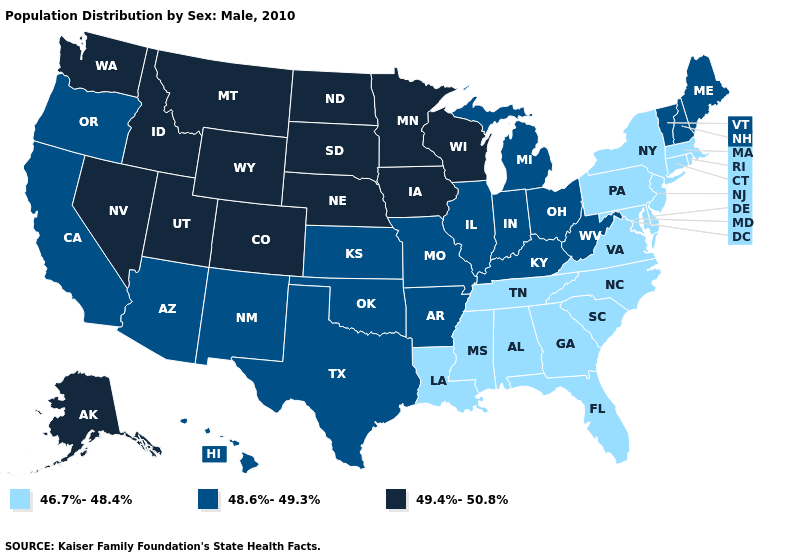Does Florida have the lowest value in the USA?
Write a very short answer. Yes. What is the value of Maine?
Write a very short answer. 48.6%-49.3%. Which states have the lowest value in the USA?
Concise answer only. Alabama, Connecticut, Delaware, Florida, Georgia, Louisiana, Maryland, Massachusetts, Mississippi, New Jersey, New York, North Carolina, Pennsylvania, Rhode Island, South Carolina, Tennessee, Virginia. Among the states that border New Hampshire , which have the lowest value?
Be succinct. Massachusetts. Name the states that have a value in the range 48.6%-49.3%?
Answer briefly. Arizona, Arkansas, California, Hawaii, Illinois, Indiana, Kansas, Kentucky, Maine, Michigan, Missouri, New Hampshire, New Mexico, Ohio, Oklahoma, Oregon, Texas, Vermont, West Virginia. How many symbols are there in the legend?
Be succinct. 3. Name the states that have a value in the range 46.7%-48.4%?
Be succinct. Alabama, Connecticut, Delaware, Florida, Georgia, Louisiana, Maryland, Massachusetts, Mississippi, New Jersey, New York, North Carolina, Pennsylvania, Rhode Island, South Carolina, Tennessee, Virginia. Is the legend a continuous bar?
Concise answer only. No. Name the states that have a value in the range 48.6%-49.3%?
Be succinct. Arizona, Arkansas, California, Hawaii, Illinois, Indiana, Kansas, Kentucky, Maine, Michigan, Missouri, New Hampshire, New Mexico, Ohio, Oklahoma, Oregon, Texas, Vermont, West Virginia. Among the states that border Nebraska , which have the highest value?
Short answer required. Colorado, Iowa, South Dakota, Wyoming. Name the states that have a value in the range 49.4%-50.8%?
Short answer required. Alaska, Colorado, Idaho, Iowa, Minnesota, Montana, Nebraska, Nevada, North Dakota, South Dakota, Utah, Washington, Wisconsin, Wyoming. How many symbols are there in the legend?
Write a very short answer. 3. Name the states that have a value in the range 48.6%-49.3%?
Be succinct. Arizona, Arkansas, California, Hawaii, Illinois, Indiana, Kansas, Kentucky, Maine, Michigan, Missouri, New Hampshire, New Mexico, Ohio, Oklahoma, Oregon, Texas, Vermont, West Virginia. Among the states that border Mississippi , which have the lowest value?
Keep it brief. Alabama, Louisiana, Tennessee. What is the highest value in the USA?
Keep it brief. 49.4%-50.8%. 